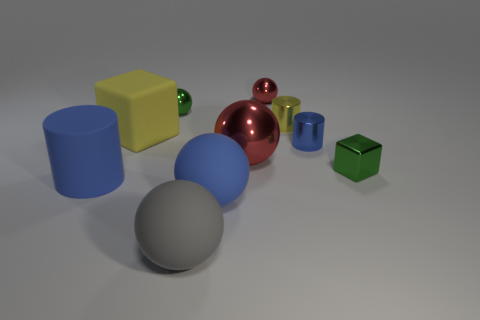How big is the thing that is both on the right side of the big yellow block and on the left side of the gray rubber ball?
Your answer should be very brief. Small. There is a rubber block; are there any green metal balls on the left side of it?
Your answer should be compact. No. How many objects are either tiny shiny things behind the large yellow cube or metal cylinders?
Make the answer very short. 4. How many green cubes are on the left side of the green thing in front of the yellow cube?
Give a very brief answer. 0. Is the number of small green objects in front of the green block less than the number of yellow cylinders in front of the big blue rubber ball?
Your answer should be compact. No. There is a tiny green metallic object that is on the right side of the tiny green object that is behind the small metal block; what shape is it?
Your response must be concise. Cube. How many other objects are there of the same material as the tiny blue thing?
Ensure brevity in your answer.  5. Are there any other things that are the same size as the metal block?
Provide a short and direct response. Yes. Are there more large purple rubber objects than large blue spheres?
Your response must be concise. No. How big is the metallic sphere in front of the tiny ball that is to the left of the small sphere that is right of the green metallic sphere?
Make the answer very short. Large. 